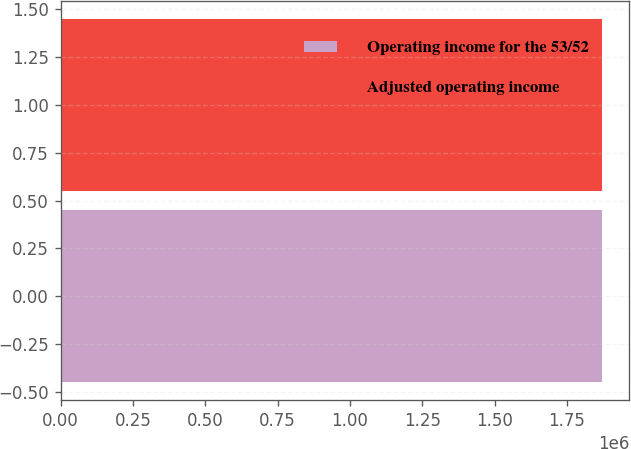Convert chart to OTSL. <chart><loc_0><loc_0><loc_500><loc_500><bar_chart><fcel>Operating income for the 53/52<fcel>Adjusted operating income<nl><fcel>1.87221e+06<fcel>1.87221e+06<nl></chart> 